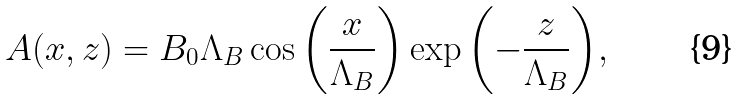Convert formula to latex. <formula><loc_0><loc_0><loc_500><loc_500>A ( x , z ) = B _ { 0 } \Lambda _ { B } \cos { \left ( \frac { x } { \Lambda _ { B } } \right ) } \exp { \left ( - \frac { z } { \Lambda _ { B } } \right ) } ,</formula> 